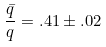<formula> <loc_0><loc_0><loc_500><loc_500>\frac { \bar { q } } { q } = . 4 1 \pm . 0 2</formula> 